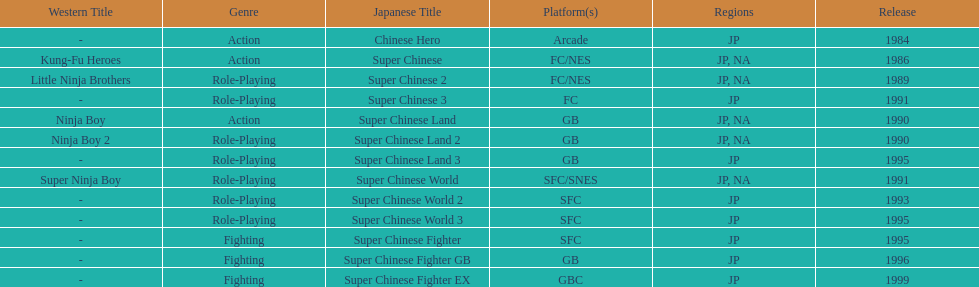On which platforms were the most titles launched? GB. 